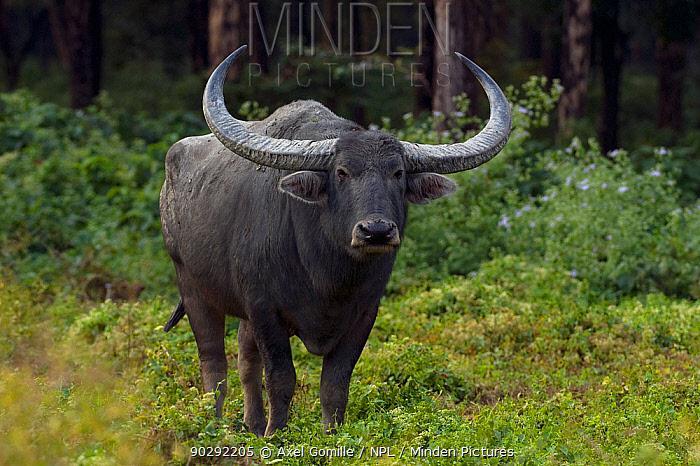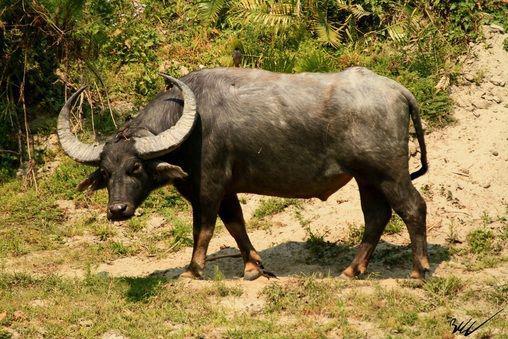The first image is the image on the left, the second image is the image on the right. Examine the images to the left and right. Is the description "The tail on the cow on the right is seen behind it." accurate? Answer yes or no. Yes. The first image is the image on the left, the second image is the image on the right. For the images shown, is this caption "There are two buffalos facing away from each other." true? Answer yes or no. No. 